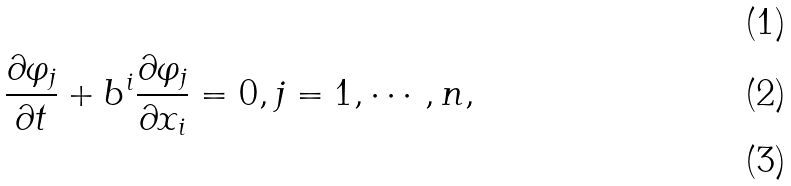<formula> <loc_0><loc_0><loc_500><loc_500>\\ \frac { \partial \varphi _ { j } } { \partial t } + b ^ { i } \frac { \partial \varphi _ { j } } { \partial x _ { i } } = 0 , j = 1 , \cdots , n , \\</formula> 